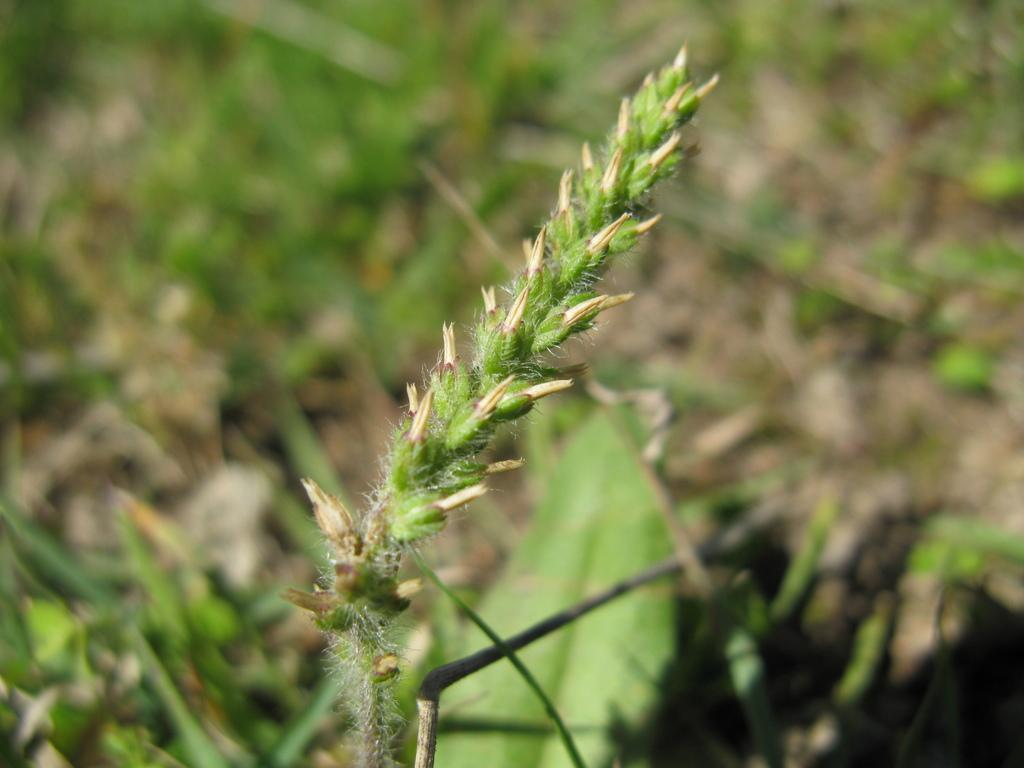What is the main subject of the image? There is a plant in the image. What can be seen in the background of the image? There are green leaves in the background of the image. How would you describe the background of the image? The background is slightly blurred. What type of tax is being discussed in the image? There is no discussion of tax in the image; it features a plant and green leaves in the background. 